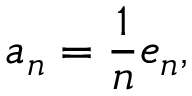Convert formula to latex. <formula><loc_0><loc_0><loc_500><loc_500>a _ { n } = { \frac { 1 } { n } } e _ { n } ,</formula> 